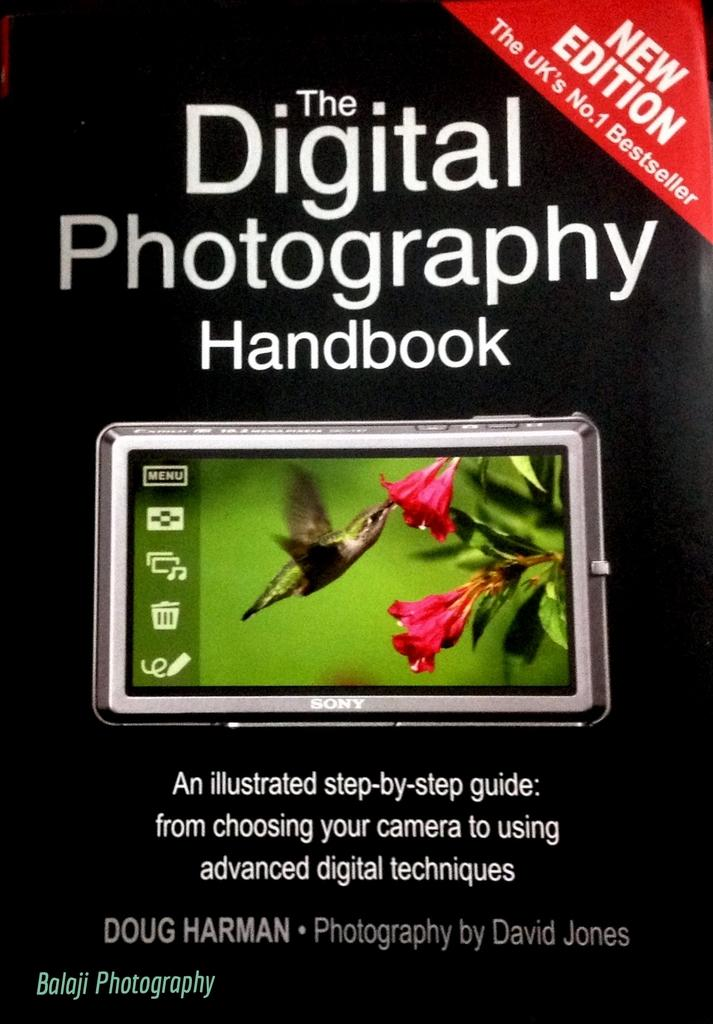What is the purpose of the image in the context of the book? The image is the cover page of a book. What type of animal can be seen in the image? There is a bird in the image. What is the bird doing in the image? The bird is eating pollen grains in the image. Where are the pollen grains located? The pollen grains are in a flower. How many clover leaves are visible in the image? There are no clover leaves present in the image. What type of pies is the bird baking in the image? There is no indication of pies or baking in the image; the bird is eating pollen grains from a flower. 